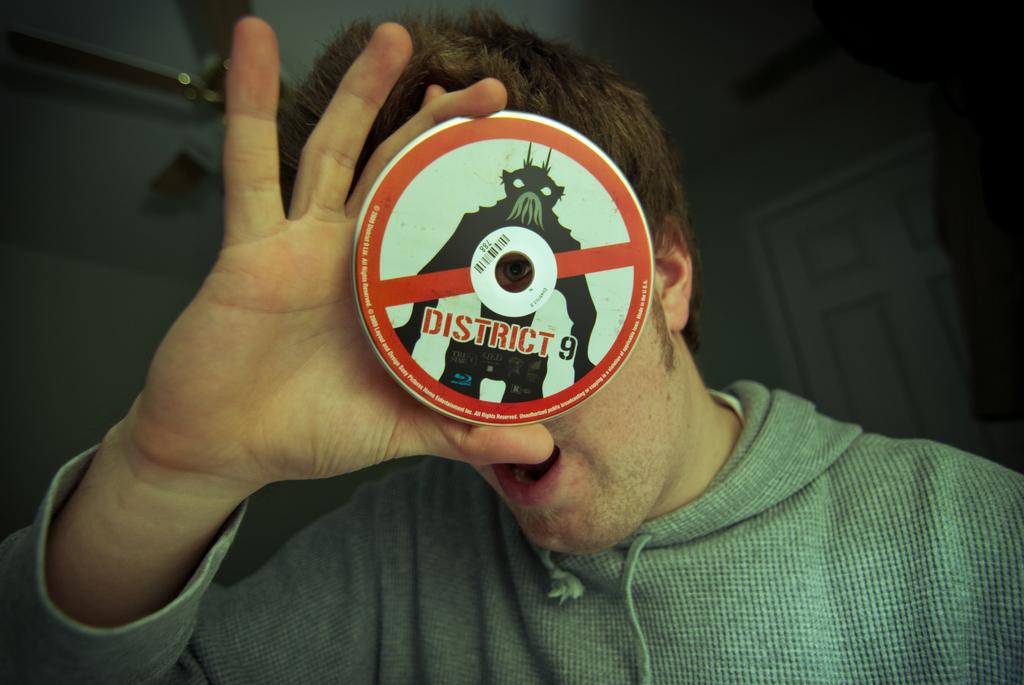Who or what is the main subject in the image? There is a person in the image. What is the person holding in the image? The person is holding a compact disc. What can be seen in the background of the image? There is a door and a wall in the background of the image. What type of game is the person playing in the image? There is no game present in the image; the person is holding a compact disc. What kind of bag is the person carrying in the image? There is no bag visible in the image; the person is holding a compact disc. 